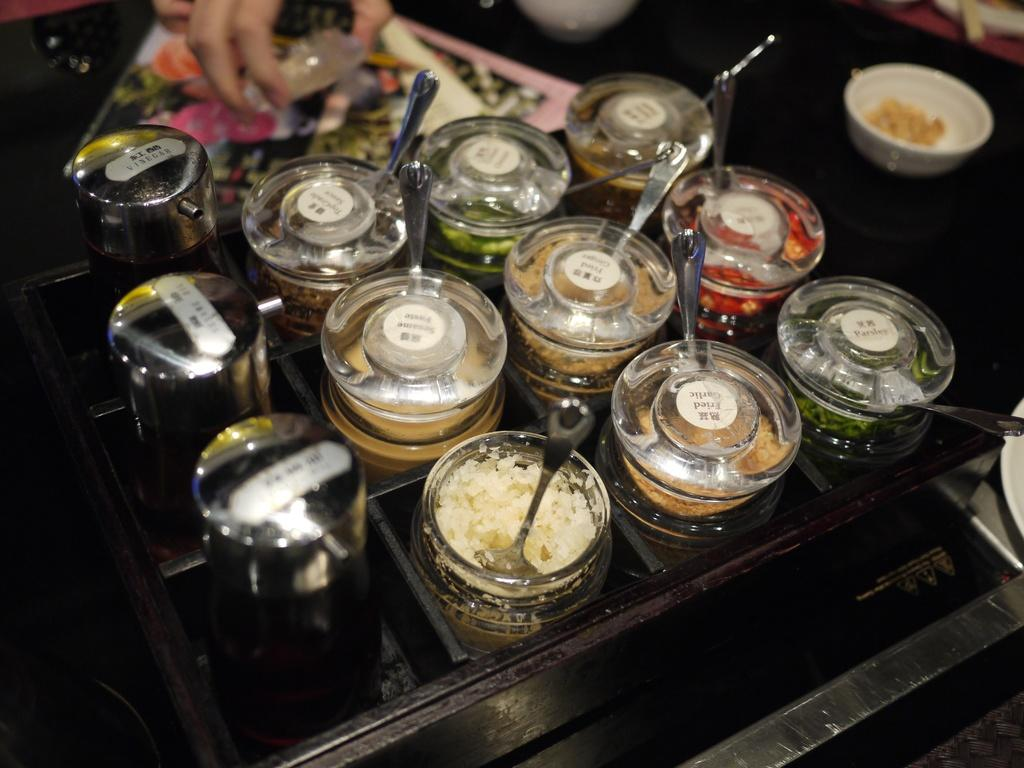What is located at the bottom of the image? There is a table at the bottom of the image. What can be found on the table in the image? There are ingredients, a box, bowls, and papers on the table. How many containers are visible on the table? There are bowls on the table. What might be used for writing or reading on the table? Papers are present on the table. What type of squirrel is sitting on the table in the image? There is no squirrel present on the table in the image. What flavor of ingredients can be seen on the table? The provided facts do not mention any specific flavors of ingredients; only their presence is noted. 